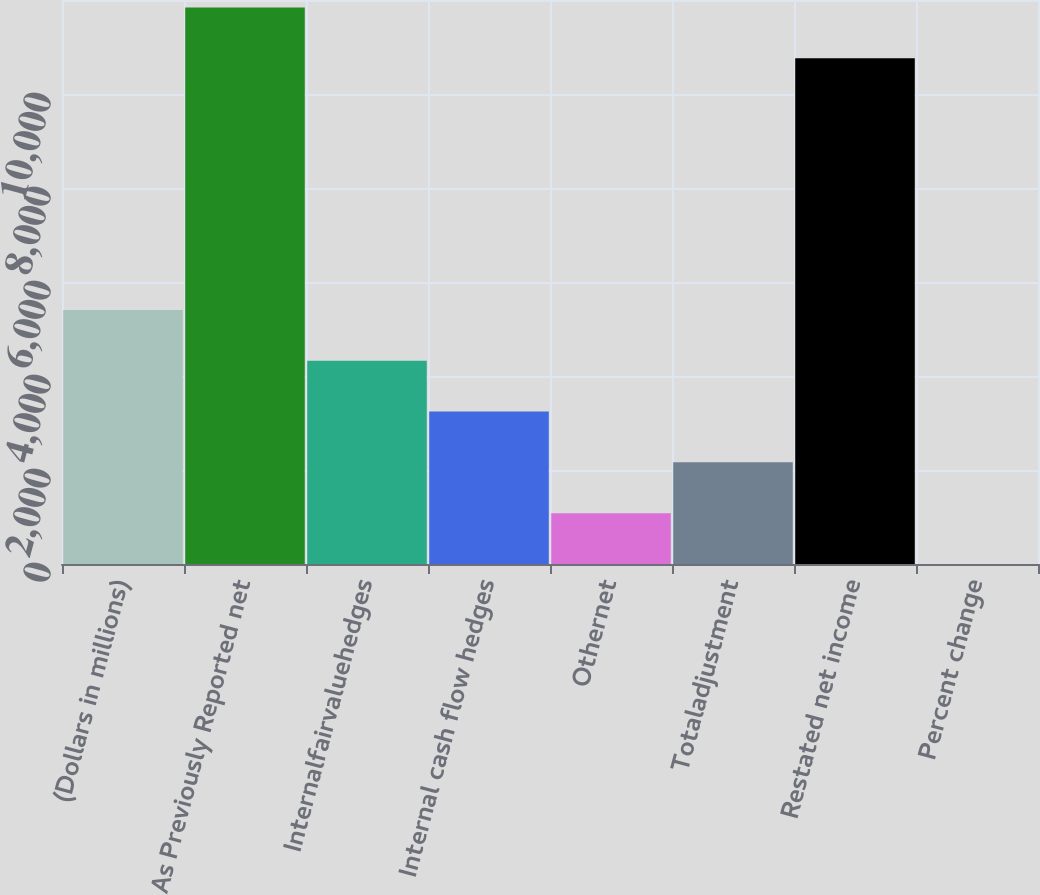Convert chart to OTSL. <chart><loc_0><loc_0><loc_500><loc_500><bar_chart><fcel>(Dollars in millions)<fcel>As Previously Reported net<fcel>Internalfairvaluehedges<fcel>Internal cash flow hedges<fcel>Othernet<fcel>Totaladjustment<fcel>Restated net income<fcel>Percent change<nl><fcel>5405.25<fcel>11843<fcel>4324.3<fcel>3243.35<fcel>1081.45<fcel>2162.4<fcel>10762<fcel>0.5<nl></chart> 